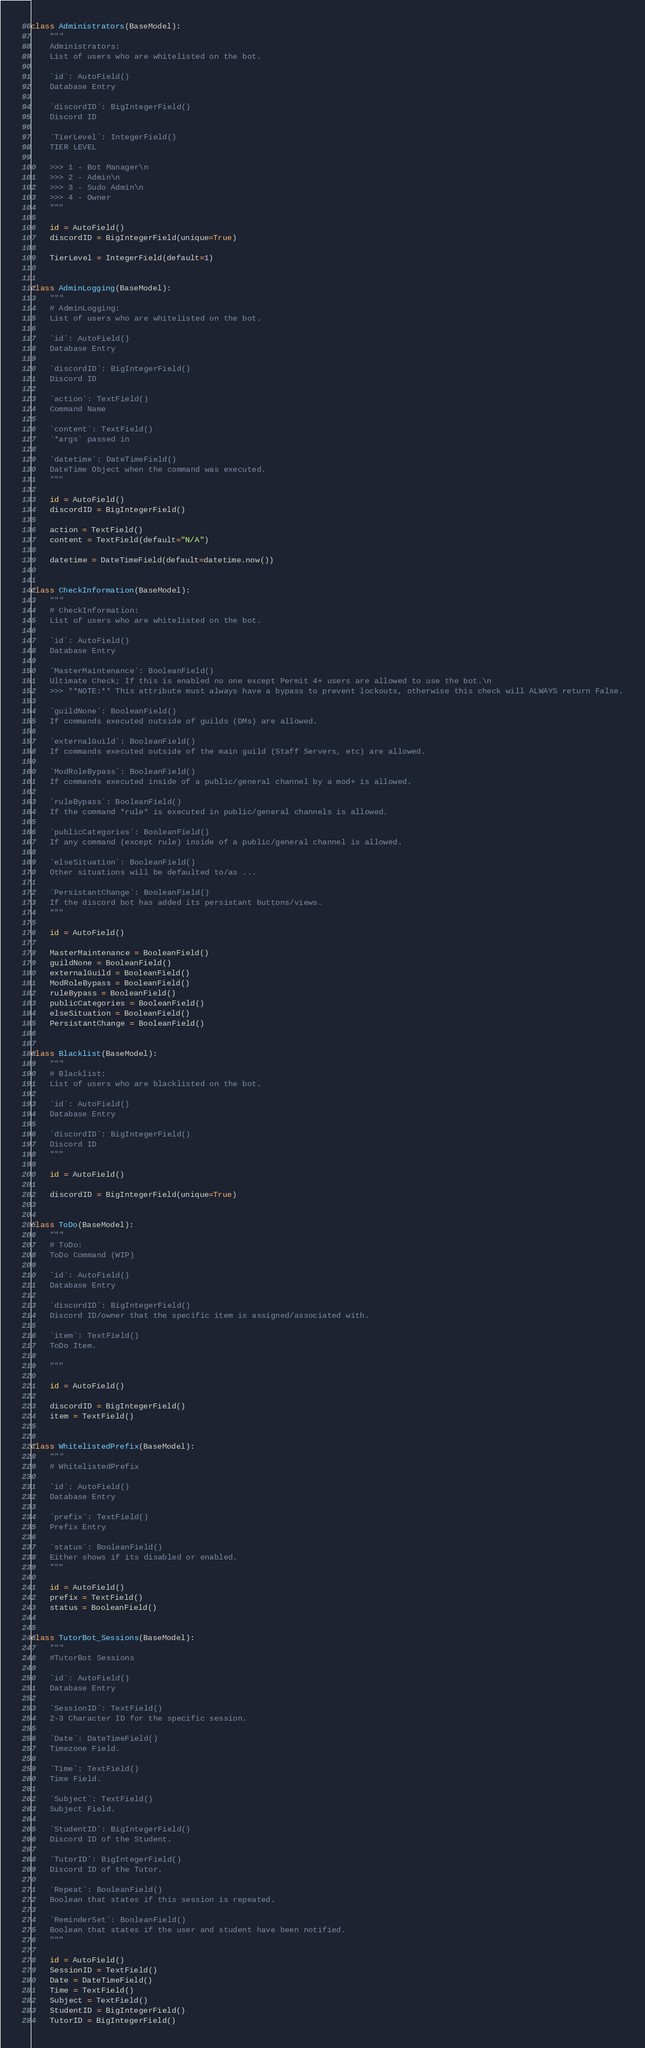Convert code to text. <code><loc_0><loc_0><loc_500><loc_500><_Python_>
class Administrators(BaseModel):
    """
    Administrators:
    List of users who are whitelisted on the bot.

    `id`: AutoField()
    Database Entry

    `discordID`: BigIntegerField()
    Discord ID

    `TierLevel`: IntegerField()
    TIER LEVEL

    >>> 1 - Bot Manager\n
    >>> 2 - Admin\n
    >>> 3 - Sudo Admin\n
    >>> 4 - Owner
    """

    id = AutoField()
    discordID = BigIntegerField(unique=True)

    TierLevel = IntegerField(default=1)


class AdminLogging(BaseModel):
    """
    # AdminLogging:
    List of users who are whitelisted on the bot.

    `id`: AutoField()
    Database Entry

    `discordID`: BigIntegerField()
    Discord ID

    `action`: TextField()
    Command Name

    `content`: TextField()
    `*args` passed in

    `datetime`: DateTimeField()
    DateTime Object when the command was executed.
    """

    id = AutoField()
    discordID = BigIntegerField()

    action = TextField()
    content = TextField(default="N/A")

    datetime = DateTimeField(default=datetime.now())


class CheckInformation(BaseModel):
    """
    # CheckInformation:
    List of users who are whitelisted on the bot.

    `id`: AutoField()
    Database Entry

    `MasterMaintenance`: BooleanField()
    Ultimate Check; If this is enabled no one except Permit 4+ users are allowed to use the bot.\n
    >>> **NOTE:** This attribute must always have a bypass to prevent lockouts, otherwise this check will ALWAYS return False.

    `guildNone`: BooleanField()
    If commands executed outside of guilds (DMs) are allowed.

    `externalGuild`: BooleanField()
    If commands executed outside of the main guild (Staff Servers, etc) are allowed.

    `ModRoleBypass`: BooleanField()
    If commands executed inside of a public/general channel by a mod+ is allowed.

    `ruleBypass`: BooleanField()
    If the command *rule* is executed in public/general channels is allowed.

    `publicCategories`: BooleanField()
    If any command (except rule) inside of a public/general channel is allowed.

    `elseSituation`: BooleanField()
    Other situations will be defaulted to/as ...

    `PersistantChange`: BooleanField()
    If the discord bot has added its persistant buttons/views.
    """

    id = AutoField()

    MasterMaintenance = BooleanField()
    guildNone = BooleanField()
    externalGuild = BooleanField()
    ModRoleBypass = BooleanField()
    ruleBypass = BooleanField()
    publicCategories = BooleanField()
    elseSituation = BooleanField()
    PersistantChange = BooleanField()


class Blacklist(BaseModel):
    """
    # Blacklist:
    List of users who are blacklisted on the bot.

    `id`: AutoField()
    Database Entry

    `discordID`: BigIntegerField()
    Discord ID
    """

    id = AutoField()

    discordID = BigIntegerField(unique=True)


class ToDo(BaseModel):
    """
    # ToDo:
    ToDo Command (WIP)

    `id`: AutoField()
    Database Entry

    `discordID`: BigIntegerField()
    Discord ID/owner that the specific item is assigned/associated with.

    `item`: TextField()
    ToDo Item.

    """

    id = AutoField()

    discordID = BigIntegerField()
    item = TextField()


class WhitelistedPrefix(BaseModel):
    """
    # WhitelistedPrefix

    `id`: AutoField()
    Database Entry

    `prefix`: TextField()
    Prefix Entry

    `status`: BooleanField()
    Either shows if its disabled or enabled.
    """

    id = AutoField()
    prefix = TextField()
    status = BooleanField()


class TutorBot_Sessions(BaseModel):
    """
    #TutorBot Sessions

    `id`: AutoField()
    Database Entry

    `SessionID`: TextField()
    2-3 Character ID for the specific session.

    `Date`: DateTimeField()
    Timezone Field.

    `Time`: TextField()
    Time Field.

    `Subject`: TextField()
    Subject Field.

    `StudentID`: BigIntegerField()
    Discord ID of the Student.

    `TutorID`: BigIntegerField()
    Discord ID of the Tutor.

    `Repeat`: BooleanField()
    Boolean that states if this session is repeated.

    `ReminderSet`: BooleanField()
    Boolean that states if the user and student have been notified.
    """

    id = AutoField()
    SessionID = TextField()
    Date = DateTimeField()
    Time = TextField()
    Subject = TextField()
    StudentID = BigIntegerField()
    TutorID = BigIntegerField()</code> 